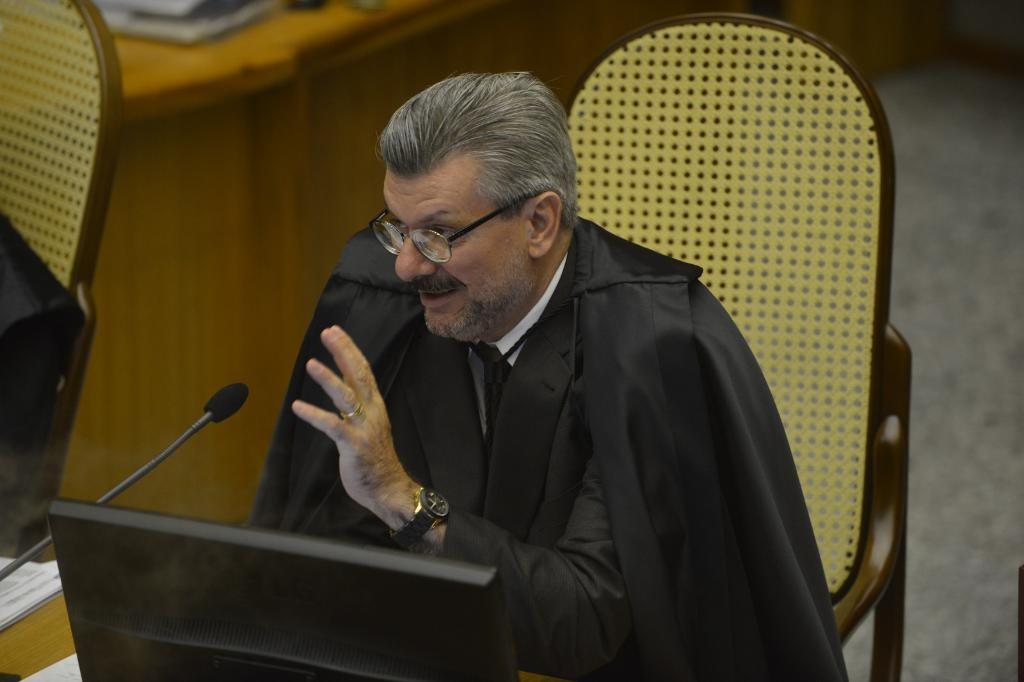What type of furniture is present in the image? There are chairs in the image. Where is the microphone located in the image? The microphone is on the left side of the image. What is the person wearing in the image? The person is wearing a black coat. What is the position of the person in the image? The person is sitting on a chair. What can be seen at the top of the image? There is a table at the top of the image. Can you hear any songs being sung by the person with the boat in the image? There is no boat or singing activity present in the image. What type of soap is being used by the person in the image? There is no soap or washing activity present in the image. 